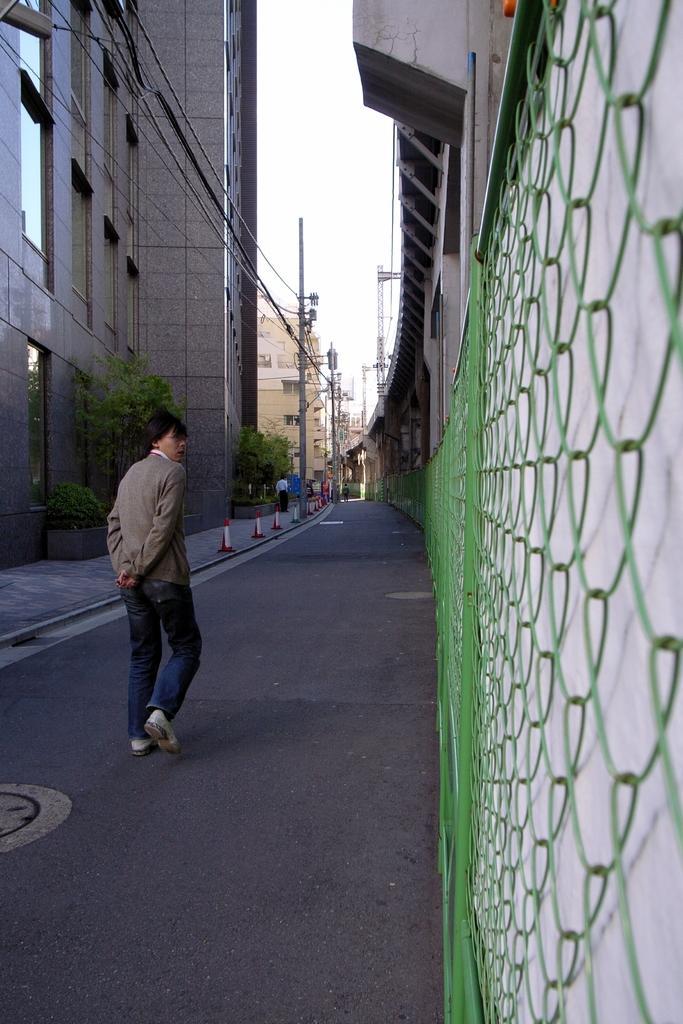Could you give a brief overview of what you see in this image? The picture is taken on the street of a city. In the center of the picture there is the road, on the road there is a person walking. In the background there are current polls, cables, buildings, trees and a person. On the left there are buildings, windows, plants and cables. On the right there are building, net and wall. 